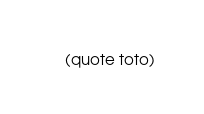<code> <loc_0><loc_0><loc_500><loc_500><_Scheme_>(quote toto)
</code> 